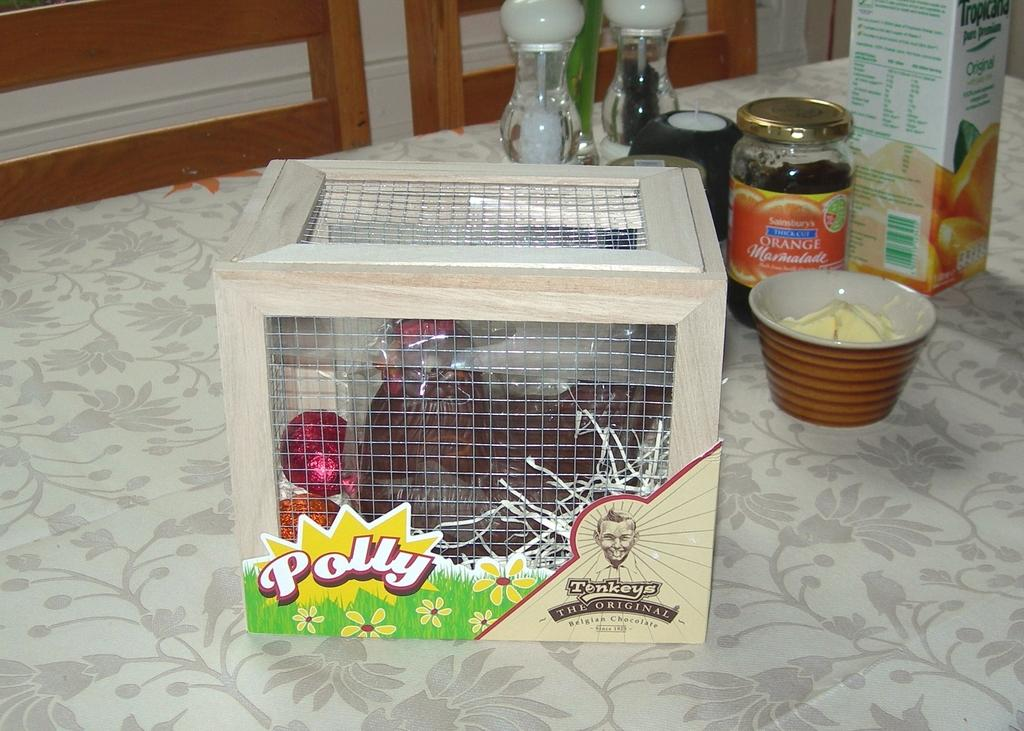<image>
Write a terse but informative summary of the picture. Belgian chocolate inside of a box that looks like a cage and on top of a white table with a flower patter cloth on top. 